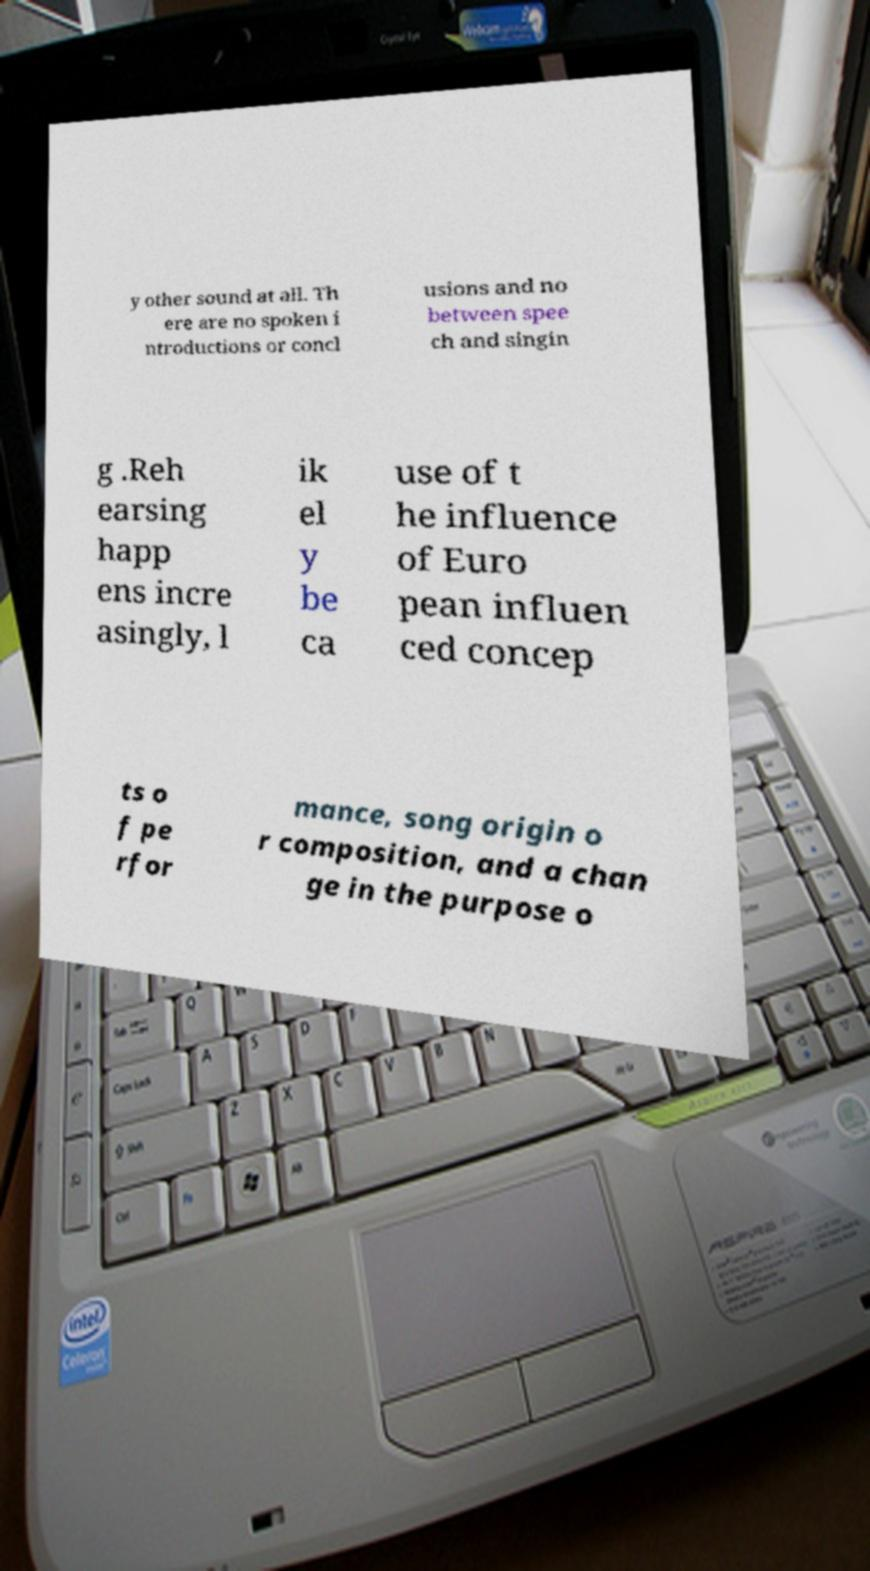Could you assist in decoding the text presented in this image and type it out clearly? y other sound at all. Th ere are no spoken i ntroductions or concl usions and no between spee ch and singin g .Reh earsing happ ens incre asingly, l ik el y be ca use of t he influence of Euro pean influen ced concep ts o f pe rfor mance, song origin o r composition, and a chan ge in the purpose o 